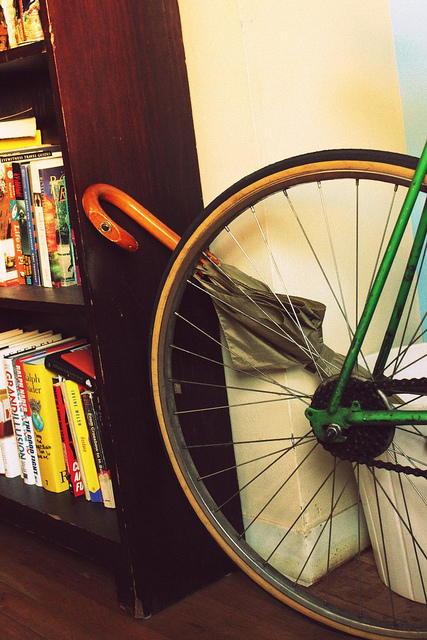How many books can you see? 3 